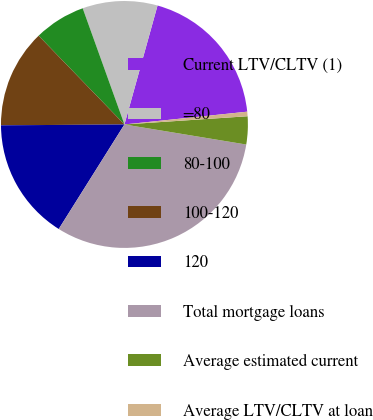Convert chart. <chart><loc_0><loc_0><loc_500><loc_500><pie_chart><fcel>Current LTV/CLTV (1)<fcel>=80<fcel>80-100<fcel>100-120<fcel>120<fcel>Total mortgage loans<fcel>Average estimated current<fcel>Average LTV/CLTV at loan<nl><fcel>19.03%<fcel>9.81%<fcel>6.74%<fcel>12.88%<fcel>15.96%<fcel>31.33%<fcel>3.66%<fcel>0.59%<nl></chart> 